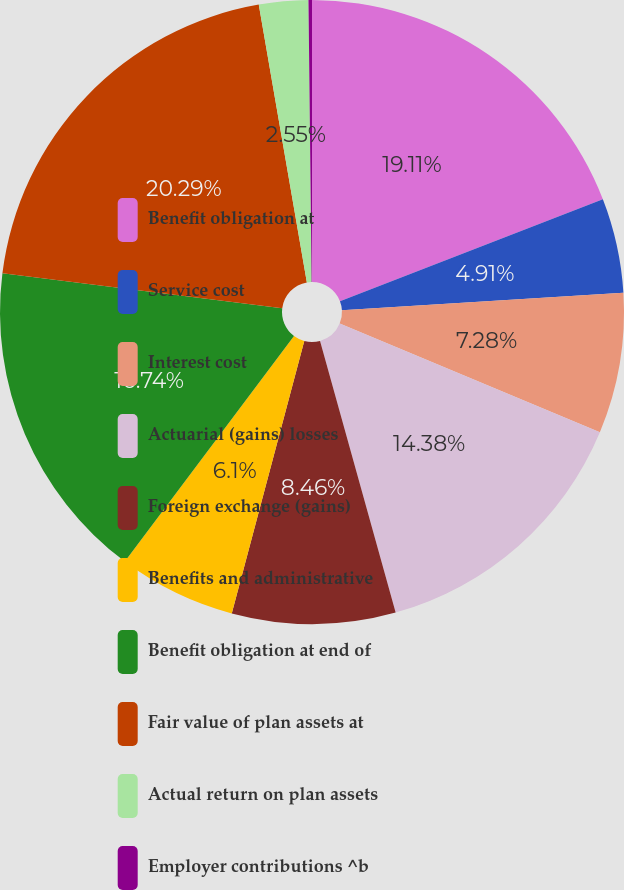<chart> <loc_0><loc_0><loc_500><loc_500><pie_chart><fcel>Benefit obligation at<fcel>Service cost<fcel>Interest cost<fcel>Actuarial (gains) losses<fcel>Foreign exchange (gains)<fcel>Benefits and administrative<fcel>Benefit obligation at end of<fcel>Fair value of plan assets at<fcel>Actual return on plan assets<fcel>Employer contributions ^b<nl><fcel>19.11%<fcel>4.91%<fcel>7.28%<fcel>14.38%<fcel>8.46%<fcel>6.1%<fcel>16.74%<fcel>20.29%<fcel>2.55%<fcel>0.18%<nl></chart> 